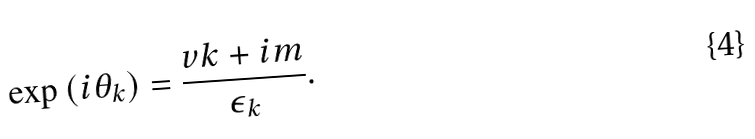Convert formula to latex. <formula><loc_0><loc_0><loc_500><loc_500>\exp \left ( i \theta _ { k } \right ) = \frac { v k + i m } { \epsilon _ { k } } .</formula> 